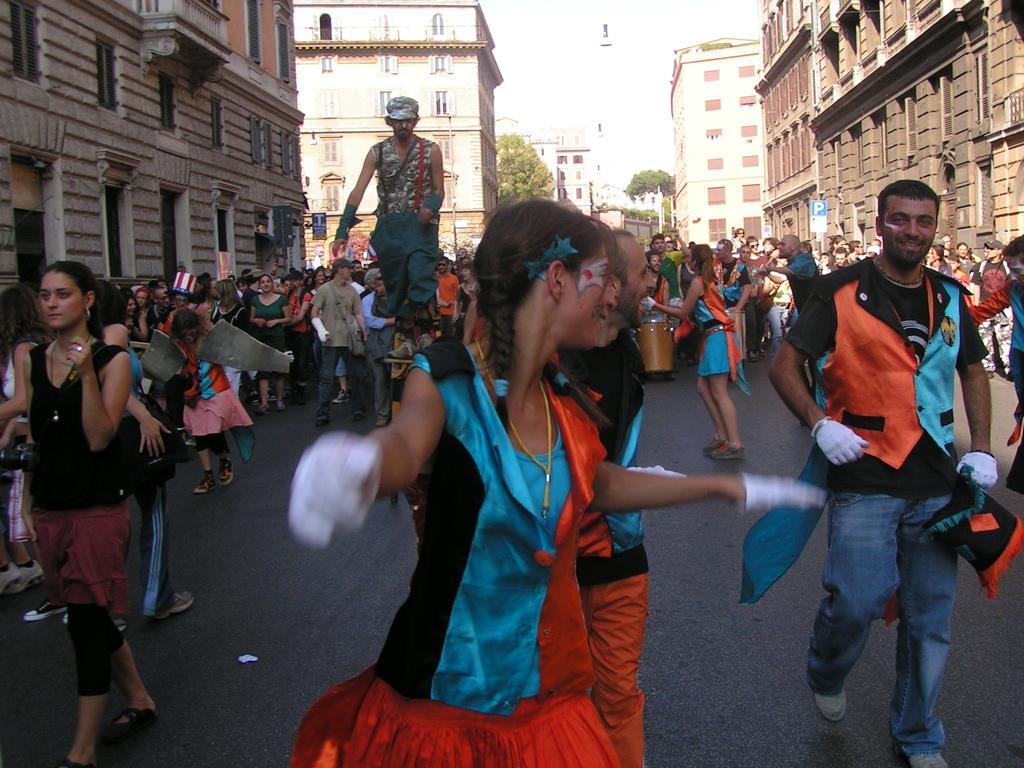In one or two sentences, can you explain what this image depicts? In the middle of the image few people are walking and standing and holding something in their hands. Behind them there are some trees and buildings. 